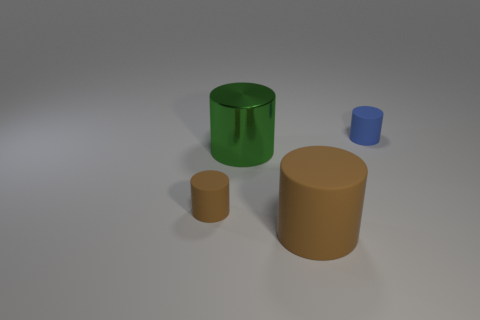Add 3 rubber objects. How many objects exist? 7 Subtract all green cylinders. How many cylinders are left? 3 Subtract all green cylinders. How many cylinders are left? 3 Subtract 1 cylinders. How many cylinders are left? 3 Subtract all purple cylinders. Subtract all green blocks. How many cylinders are left? 4 Subtract all gray cubes. How many gray cylinders are left? 0 Subtract all rubber cylinders. Subtract all large green metal things. How many objects are left? 0 Add 4 large brown matte things. How many large brown matte things are left? 5 Add 2 cyan metallic things. How many cyan metallic things exist? 2 Subtract 0 gray cylinders. How many objects are left? 4 